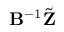Convert formula to latex. <formula><loc_0><loc_0><loc_500><loc_500>B ^ { - 1 } \tilde { Z }</formula> 